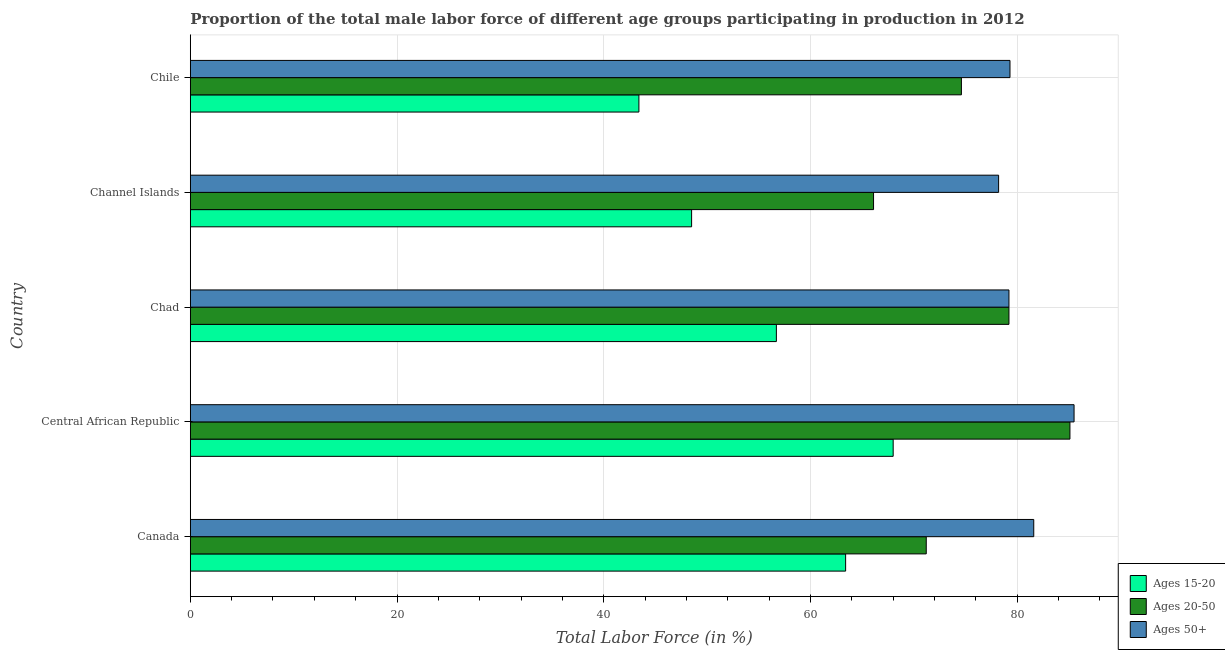How many different coloured bars are there?
Give a very brief answer. 3. How many groups of bars are there?
Keep it short and to the point. 5. Are the number of bars on each tick of the Y-axis equal?
Offer a terse response. Yes. How many bars are there on the 1st tick from the top?
Your response must be concise. 3. How many bars are there on the 1st tick from the bottom?
Your answer should be compact. 3. In how many cases, is the number of bars for a given country not equal to the number of legend labels?
Keep it short and to the point. 0. What is the percentage of male labor force within the age group 20-50 in Chile?
Provide a short and direct response. 74.6. Across all countries, what is the maximum percentage of male labor force within the age group 15-20?
Ensure brevity in your answer.  68. Across all countries, what is the minimum percentage of male labor force within the age group 15-20?
Offer a terse response. 43.4. In which country was the percentage of male labor force within the age group 15-20 maximum?
Your answer should be very brief. Central African Republic. In which country was the percentage of male labor force within the age group 20-50 minimum?
Your response must be concise. Channel Islands. What is the total percentage of male labor force within the age group 20-50 in the graph?
Keep it short and to the point. 376.2. What is the difference between the percentage of male labor force within the age group 15-20 in Central African Republic and that in Channel Islands?
Your answer should be very brief. 19.5. What is the difference between the percentage of male labor force within the age group 15-20 in Central African Republic and the percentage of male labor force within the age group 20-50 in Canada?
Your answer should be compact. -3.2. What is the average percentage of male labor force within the age group 15-20 per country?
Offer a terse response. 56. What is the difference between the percentage of male labor force within the age group 15-20 and percentage of male labor force within the age group 20-50 in Chad?
Offer a terse response. -22.5. In how many countries, is the percentage of male labor force within the age group 15-20 greater than 56 %?
Provide a succinct answer. 3. What is the ratio of the percentage of male labor force within the age group 15-20 in Chad to that in Channel Islands?
Your response must be concise. 1.17. What is the difference between the highest and the lowest percentage of male labor force within the age group 15-20?
Keep it short and to the point. 24.6. Is the sum of the percentage of male labor force above age 50 in Chad and Chile greater than the maximum percentage of male labor force within the age group 15-20 across all countries?
Offer a terse response. Yes. What does the 2nd bar from the top in Chile represents?
Provide a short and direct response. Ages 20-50. What does the 3rd bar from the bottom in Central African Republic represents?
Your answer should be compact. Ages 50+. Is it the case that in every country, the sum of the percentage of male labor force within the age group 15-20 and percentage of male labor force within the age group 20-50 is greater than the percentage of male labor force above age 50?
Provide a succinct answer. Yes. Are all the bars in the graph horizontal?
Give a very brief answer. Yes. Does the graph contain any zero values?
Ensure brevity in your answer.  No. Does the graph contain grids?
Ensure brevity in your answer.  Yes. How many legend labels are there?
Offer a terse response. 3. How are the legend labels stacked?
Your answer should be compact. Vertical. What is the title of the graph?
Provide a succinct answer. Proportion of the total male labor force of different age groups participating in production in 2012. Does "Male employers" appear as one of the legend labels in the graph?
Your answer should be very brief. No. What is the label or title of the X-axis?
Your answer should be compact. Total Labor Force (in %). What is the label or title of the Y-axis?
Provide a short and direct response. Country. What is the Total Labor Force (in %) of Ages 15-20 in Canada?
Keep it short and to the point. 63.4. What is the Total Labor Force (in %) of Ages 20-50 in Canada?
Your answer should be very brief. 71.2. What is the Total Labor Force (in %) in Ages 50+ in Canada?
Ensure brevity in your answer.  81.6. What is the Total Labor Force (in %) in Ages 20-50 in Central African Republic?
Your answer should be compact. 85.1. What is the Total Labor Force (in %) in Ages 50+ in Central African Republic?
Offer a terse response. 85.5. What is the Total Labor Force (in %) of Ages 15-20 in Chad?
Your response must be concise. 56.7. What is the Total Labor Force (in %) of Ages 20-50 in Chad?
Ensure brevity in your answer.  79.2. What is the Total Labor Force (in %) in Ages 50+ in Chad?
Give a very brief answer. 79.2. What is the Total Labor Force (in %) in Ages 15-20 in Channel Islands?
Offer a terse response. 48.5. What is the Total Labor Force (in %) in Ages 20-50 in Channel Islands?
Your answer should be compact. 66.1. What is the Total Labor Force (in %) of Ages 50+ in Channel Islands?
Provide a short and direct response. 78.2. What is the Total Labor Force (in %) in Ages 15-20 in Chile?
Your response must be concise. 43.4. What is the Total Labor Force (in %) in Ages 20-50 in Chile?
Provide a succinct answer. 74.6. What is the Total Labor Force (in %) in Ages 50+ in Chile?
Offer a terse response. 79.3. Across all countries, what is the maximum Total Labor Force (in %) of Ages 15-20?
Provide a short and direct response. 68. Across all countries, what is the maximum Total Labor Force (in %) in Ages 20-50?
Keep it short and to the point. 85.1. Across all countries, what is the maximum Total Labor Force (in %) in Ages 50+?
Provide a short and direct response. 85.5. Across all countries, what is the minimum Total Labor Force (in %) of Ages 15-20?
Ensure brevity in your answer.  43.4. Across all countries, what is the minimum Total Labor Force (in %) of Ages 20-50?
Offer a very short reply. 66.1. Across all countries, what is the minimum Total Labor Force (in %) of Ages 50+?
Ensure brevity in your answer.  78.2. What is the total Total Labor Force (in %) of Ages 15-20 in the graph?
Ensure brevity in your answer.  280. What is the total Total Labor Force (in %) in Ages 20-50 in the graph?
Your response must be concise. 376.2. What is the total Total Labor Force (in %) in Ages 50+ in the graph?
Your answer should be very brief. 403.8. What is the difference between the Total Labor Force (in %) in Ages 15-20 in Canada and that in Central African Republic?
Make the answer very short. -4.6. What is the difference between the Total Labor Force (in %) of Ages 50+ in Canada and that in Central African Republic?
Ensure brevity in your answer.  -3.9. What is the difference between the Total Labor Force (in %) in Ages 15-20 in Canada and that in Chad?
Provide a short and direct response. 6.7. What is the difference between the Total Labor Force (in %) in Ages 15-20 in Canada and that in Channel Islands?
Your answer should be very brief. 14.9. What is the difference between the Total Labor Force (in %) in Ages 50+ in Canada and that in Channel Islands?
Your response must be concise. 3.4. What is the difference between the Total Labor Force (in %) of Ages 50+ in Canada and that in Chile?
Your answer should be compact. 2.3. What is the difference between the Total Labor Force (in %) of Ages 15-20 in Central African Republic and that in Chad?
Offer a very short reply. 11.3. What is the difference between the Total Labor Force (in %) in Ages 50+ in Central African Republic and that in Chad?
Ensure brevity in your answer.  6.3. What is the difference between the Total Labor Force (in %) of Ages 20-50 in Central African Republic and that in Channel Islands?
Give a very brief answer. 19. What is the difference between the Total Labor Force (in %) in Ages 15-20 in Central African Republic and that in Chile?
Your answer should be compact. 24.6. What is the difference between the Total Labor Force (in %) in Ages 50+ in Central African Republic and that in Chile?
Provide a succinct answer. 6.2. What is the difference between the Total Labor Force (in %) in Ages 15-20 in Chad and that in Channel Islands?
Ensure brevity in your answer.  8.2. What is the difference between the Total Labor Force (in %) of Ages 20-50 in Chad and that in Channel Islands?
Your answer should be very brief. 13.1. What is the difference between the Total Labor Force (in %) in Ages 50+ in Chad and that in Channel Islands?
Make the answer very short. 1. What is the difference between the Total Labor Force (in %) in Ages 20-50 in Chad and that in Chile?
Your response must be concise. 4.6. What is the difference between the Total Labor Force (in %) in Ages 50+ in Chad and that in Chile?
Provide a short and direct response. -0.1. What is the difference between the Total Labor Force (in %) of Ages 15-20 in Canada and the Total Labor Force (in %) of Ages 20-50 in Central African Republic?
Make the answer very short. -21.7. What is the difference between the Total Labor Force (in %) in Ages 15-20 in Canada and the Total Labor Force (in %) in Ages 50+ in Central African Republic?
Provide a succinct answer. -22.1. What is the difference between the Total Labor Force (in %) of Ages 20-50 in Canada and the Total Labor Force (in %) of Ages 50+ in Central African Republic?
Keep it short and to the point. -14.3. What is the difference between the Total Labor Force (in %) of Ages 15-20 in Canada and the Total Labor Force (in %) of Ages 20-50 in Chad?
Offer a very short reply. -15.8. What is the difference between the Total Labor Force (in %) of Ages 15-20 in Canada and the Total Labor Force (in %) of Ages 50+ in Chad?
Make the answer very short. -15.8. What is the difference between the Total Labor Force (in %) of Ages 20-50 in Canada and the Total Labor Force (in %) of Ages 50+ in Chad?
Provide a succinct answer. -8. What is the difference between the Total Labor Force (in %) of Ages 15-20 in Canada and the Total Labor Force (in %) of Ages 20-50 in Channel Islands?
Your response must be concise. -2.7. What is the difference between the Total Labor Force (in %) of Ages 15-20 in Canada and the Total Labor Force (in %) of Ages 50+ in Channel Islands?
Your answer should be compact. -14.8. What is the difference between the Total Labor Force (in %) in Ages 15-20 in Canada and the Total Labor Force (in %) in Ages 20-50 in Chile?
Your answer should be very brief. -11.2. What is the difference between the Total Labor Force (in %) in Ages 15-20 in Canada and the Total Labor Force (in %) in Ages 50+ in Chile?
Your response must be concise. -15.9. What is the difference between the Total Labor Force (in %) of Ages 20-50 in Canada and the Total Labor Force (in %) of Ages 50+ in Chile?
Your answer should be very brief. -8.1. What is the difference between the Total Labor Force (in %) in Ages 15-20 in Central African Republic and the Total Labor Force (in %) in Ages 20-50 in Chad?
Provide a succinct answer. -11.2. What is the difference between the Total Labor Force (in %) in Ages 15-20 in Central African Republic and the Total Labor Force (in %) in Ages 50+ in Chad?
Your response must be concise. -11.2. What is the difference between the Total Labor Force (in %) of Ages 20-50 in Central African Republic and the Total Labor Force (in %) of Ages 50+ in Chad?
Your answer should be very brief. 5.9. What is the difference between the Total Labor Force (in %) in Ages 15-20 in Central African Republic and the Total Labor Force (in %) in Ages 50+ in Channel Islands?
Your answer should be compact. -10.2. What is the difference between the Total Labor Force (in %) of Ages 20-50 in Central African Republic and the Total Labor Force (in %) of Ages 50+ in Channel Islands?
Give a very brief answer. 6.9. What is the difference between the Total Labor Force (in %) of Ages 15-20 in Central African Republic and the Total Labor Force (in %) of Ages 20-50 in Chile?
Your response must be concise. -6.6. What is the difference between the Total Labor Force (in %) of Ages 15-20 in Central African Republic and the Total Labor Force (in %) of Ages 50+ in Chile?
Ensure brevity in your answer.  -11.3. What is the difference between the Total Labor Force (in %) in Ages 20-50 in Central African Republic and the Total Labor Force (in %) in Ages 50+ in Chile?
Offer a terse response. 5.8. What is the difference between the Total Labor Force (in %) of Ages 15-20 in Chad and the Total Labor Force (in %) of Ages 20-50 in Channel Islands?
Ensure brevity in your answer.  -9.4. What is the difference between the Total Labor Force (in %) of Ages 15-20 in Chad and the Total Labor Force (in %) of Ages 50+ in Channel Islands?
Make the answer very short. -21.5. What is the difference between the Total Labor Force (in %) of Ages 15-20 in Chad and the Total Labor Force (in %) of Ages 20-50 in Chile?
Make the answer very short. -17.9. What is the difference between the Total Labor Force (in %) in Ages 15-20 in Chad and the Total Labor Force (in %) in Ages 50+ in Chile?
Your response must be concise. -22.6. What is the difference between the Total Labor Force (in %) of Ages 20-50 in Chad and the Total Labor Force (in %) of Ages 50+ in Chile?
Make the answer very short. -0.1. What is the difference between the Total Labor Force (in %) of Ages 15-20 in Channel Islands and the Total Labor Force (in %) of Ages 20-50 in Chile?
Your answer should be compact. -26.1. What is the difference between the Total Labor Force (in %) of Ages 15-20 in Channel Islands and the Total Labor Force (in %) of Ages 50+ in Chile?
Provide a short and direct response. -30.8. What is the average Total Labor Force (in %) in Ages 20-50 per country?
Your answer should be very brief. 75.24. What is the average Total Labor Force (in %) in Ages 50+ per country?
Ensure brevity in your answer.  80.76. What is the difference between the Total Labor Force (in %) of Ages 15-20 and Total Labor Force (in %) of Ages 20-50 in Canada?
Your answer should be very brief. -7.8. What is the difference between the Total Labor Force (in %) of Ages 15-20 and Total Labor Force (in %) of Ages 50+ in Canada?
Your answer should be very brief. -18.2. What is the difference between the Total Labor Force (in %) in Ages 20-50 and Total Labor Force (in %) in Ages 50+ in Canada?
Offer a very short reply. -10.4. What is the difference between the Total Labor Force (in %) of Ages 15-20 and Total Labor Force (in %) of Ages 20-50 in Central African Republic?
Make the answer very short. -17.1. What is the difference between the Total Labor Force (in %) in Ages 15-20 and Total Labor Force (in %) in Ages 50+ in Central African Republic?
Ensure brevity in your answer.  -17.5. What is the difference between the Total Labor Force (in %) in Ages 15-20 and Total Labor Force (in %) in Ages 20-50 in Chad?
Offer a terse response. -22.5. What is the difference between the Total Labor Force (in %) of Ages 15-20 and Total Labor Force (in %) of Ages 50+ in Chad?
Your response must be concise. -22.5. What is the difference between the Total Labor Force (in %) of Ages 20-50 and Total Labor Force (in %) of Ages 50+ in Chad?
Your answer should be compact. 0. What is the difference between the Total Labor Force (in %) of Ages 15-20 and Total Labor Force (in %) of Ages 20-50 in Channel Islands?
Your answer should be compact. -17.6. What is the difference between the Total Labor Force (in %) of Ages 15-20 and Total Labor Force (in %) of Ages 50+ in Channel Islands?
Make the answer very short. -29.7. What is the difference between the Total Labor Force (in %) in Ages 20-50 and Total Labor Force (in %) in Ages 50+ in Channel Islands?
Keep it short and to the point. -12.1. What is the difference between the Total Labor Force (in %) in Ages 15-20 and Total Labor Force (in %) in Ages 20-50 in Chile?
Give a very brief answer. -31.2. What is the difference between the Total Labor Force (in %) in Ages 15-20 and Total Labor Force (in %) in Ages 50+ in Chile?
Give a very brief answer. -35.9. What is the difference between the Total Labor Force (in %) in Ages 20-50 and Total Labor Force (in %) in Ages 50+ in Chile?
Provide a succinct answer. -4.7. What is the ratio of the Total Labor Force (in %) in Ages 15-20 in Canada to that in Central African Republic?
Your answer should be very brief. 0.93. What is the ratio of the Total Labor Force (in %) in Ages 20-50 in Canada to that in Central African Republic?
Your answer should be very brief. 0.84. What is the ratio of the Total Labor Force (in %) of Ages 50+ in Canada to that in Central African Republic?
Ensure brevity in your answer.  0.95. What is the ratio of the Total Labor Force (in %) of Ages 15-20 in Canada to that in Chad?
Your response must be concise. 1.12. What is the ratio of the Total Labor Force (in %) in Ages 20-50 in Canada to that in Chad?
Ensure brevity in your answer.  0.9. What is the ratio of the Total Labor Force (in %) in Ages 50+ in Canada to that in Chad?
Provide a short and direct response. 1.03. What is the ratio of the Total Labor Force (in %) in Ages 15-20 in Canada to that in Channel Islands?
Your answer should be compact. 1.31. What is the ratio of the Total Labor Force (in %) in Ages 20-50 in Canada to that in Channel Islands?
Your response must be concise. 1.08. What is the ratio of the Total Labor Force (in %) of Ages 50+ in Canada to that in Channel Islands?
Make the answer very short. 1.04. What is the ratio of the Total Labor Force (in %) in Ages 15-20 in Canada to that in Chile?
Your response must be concise. 1.46. What is the ratio of the Total Labor Force (in %) of Ages 20-50 in Canada to that in Chile?
Give a very brief answer. 0.95. What is the ratio of the Total Labor Force (in %) of Ages 15-20 in Central African Republic to that in Chad?
Give a very brief answer. 1.2. What is the ratio of the Total Labor Force (in %) of Ages 20-50 in Central African Republic to that in Chad?
Ensure brevity in your answer.  1.07. What is the ratio of the Total Labor Force (in %) in Ages 50+ in Central African Republic to that in Chad?
Offer a very short reply. 1.08. What is the ratio of the Total Labor Force (in %) of Ages 15-20 in Central African Republic to that in Channel Islands?
Make the answer very short. 1.4. What is the ratio of the Total Labor Force (in %) in Ages 20-50 in Central African Republic to that in Channel Islands?
Your response must be concise. 1.29. What is the ratio of the Total Labor Force (in %) in Ages 50+ in Central African Republic to that in Channel Islands?
Provide a short and direct response. 1.09. What is the ratio of the Total Labor Force (in %) of Ages 15-20 in Central African Republic to that in Chile?
Your answer should be very brief. 1.57. What is the ratio of the Total Labor Force (in %) of Ages 20-50 in Central African Republic to that in Chile?
Your answer should be compact. 1.14. What is the ratio of the Total Labor Force (in %) in Ages 50+ in Central African Republic to that in Chile?
Provide a short and direct response. 1.08. What is the ratio of the Total Labor Force (in %) in Ages 15-20 in Chad to that in Channel Islands?
Your answer should be compact. 1.17. What is the ratio of the Total Labor Force (in %) of Ages 20-50 in Chad to that in Channel Islands?
Keep it short and to the point. 1.2. What is the ratio of the Total Labor Force (in %) in Ages 50+ in Chad to that in Channel Islands?
Make the answer very short. 1.01. What is the ratio of the Total Labor Force (in %) of Ages 15-20 in Chad to that in Chile?
Provide a succinct answer. 1.31. What is the ratio of the Total Labor Force (in %) in Ages 20-50 in Chad to that in Chile?
Your answer should be compact. 1.06. What is the ratio of the Total Labor Force (in %) in Ages 50+ in Chad to that in Chile?
Offer a terse response. 1. What is the ratio of the Total Labor Force (in %) in Ages 15-20 in Channel Islands to that in Chile?
Provide a short and direct response. 1.12. What is the ratio of the Total Labor Force (in %) of Ages 20-50 in Channel Islands to that in Chile?
Keep it short and to the point. 0.89. What is the ratio of the Total Labor Force (in %) of Ages 50+ in Channel Islands to that in Chile?
Offer a very short reply. 0.99. What is the difference between the highest and the second highest Total Labor Force (in %) in Ages 15-20?
Keep it short and to the point. 4.6. What is the difference between the highest and the second highest Total Labor Force (in %) in Ages 20-50?
Provide a short and direct response. 5.9. What is the difference between the highest and the second highest Total Labor Force (in %) in Ages 50+?
Ensure brevity in your answer.  3.9. What is the difference between the highest and the lowest Total Labor Force (in %) of Ages 15-20?
Ensure brevity in your answer.  24.6. What is the difference between the highest and the lowest Total Labor Force (in %) in Ages 20-50?
Make the answer very short. 19. What is the difference between the highest and the lowest Total Labor Force (in %) in Ages 50+?
Your answer should be very brief. 7.3. 